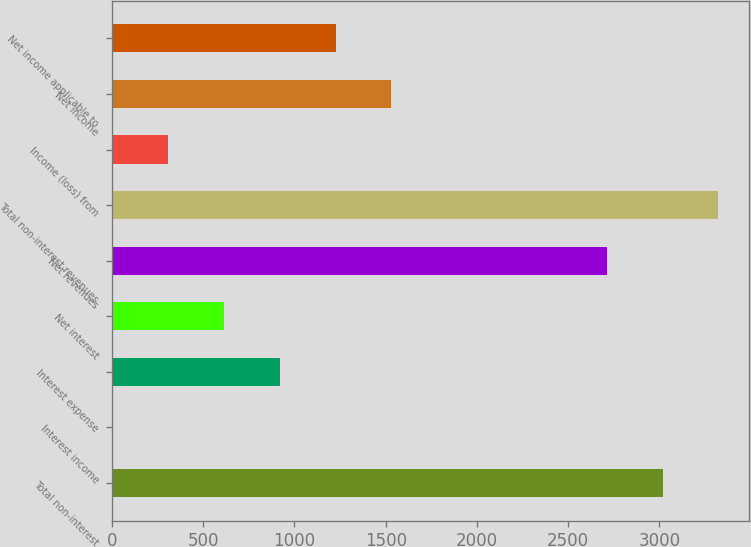Convert chart to OTSL. <chart><loc_0><loc_0><loc_500><loc_500><bar_chart><fcel>Total non-interest<fcel>Interest income<fcel>Interest expense<fcel>Net interest<fcel>Net revenues<fcel>Total non-interest revenues<fcel>Income (loss) from<fcel>Net income<fcel>Net income applicable to<nl><fcel>3017.8<fcel>2<fcel>919.4<fcel>613.6<fcel>2712<fcel>3323.6<fcel>307.8<fcel>1531<fcel>1225.2<nl></chart> 